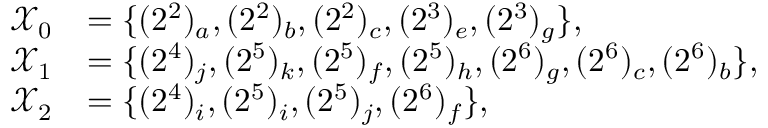Convert formula to latex. <formula><loc_0><loc_0><loc_500><loc_500>\begin{array} { r l } { \mathcal { X } _ { 0 } } & { = \{ ( 2 ^ { 2 } ) _ { a } , ( 2 ^ { 2 } ) _ { b } , ( 2 ^ { 2 } ) _ { c } , ( 2 ^ { 3 } ) _ { e } , ( 2 ^ { 3 } ) _ { g } \} , } \\ { \mathcal { X } _ { 1 } } & { = \{ ( 2 ^ { 4 } ) _ { j } , ( 2 ^ { 5 } ) _ { k } , ( 2 ^ { 5 } ) _ { f } , ( 2 ^ { 5 } ) _ { h } , ( 2 ^ { 6 } ) _ { g } , ( 2 ^ { 6 } ) _ { c } , ( 2 ^ { 6 } ) _ { b } \} , } \\ { \mathcal { X } _ { 2 } } & { = \{ ( 2 ^ { 4 } ) _ { i } , ( 2 ^ { 5 } ) _ { i } , ( 2 ^ { 5 } ) _ { j } , ( 2 ^ { 6 } ) _ { f } \} , } \end{array}</formula> 